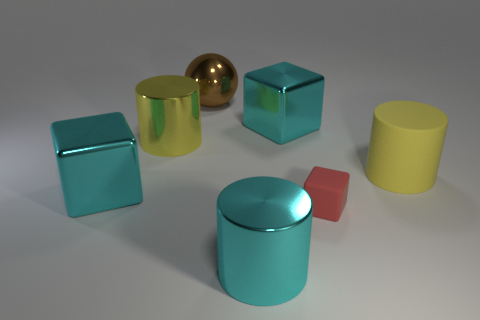What times of day do the lighting conditions in the image suggest? The soft shadows and neutral lighting in the image hint at an indoor setting, perhaps illuminated by artificial lighting rather than a specific time of day. It creates a controlled environment typically used in photography studios or product showcases. 